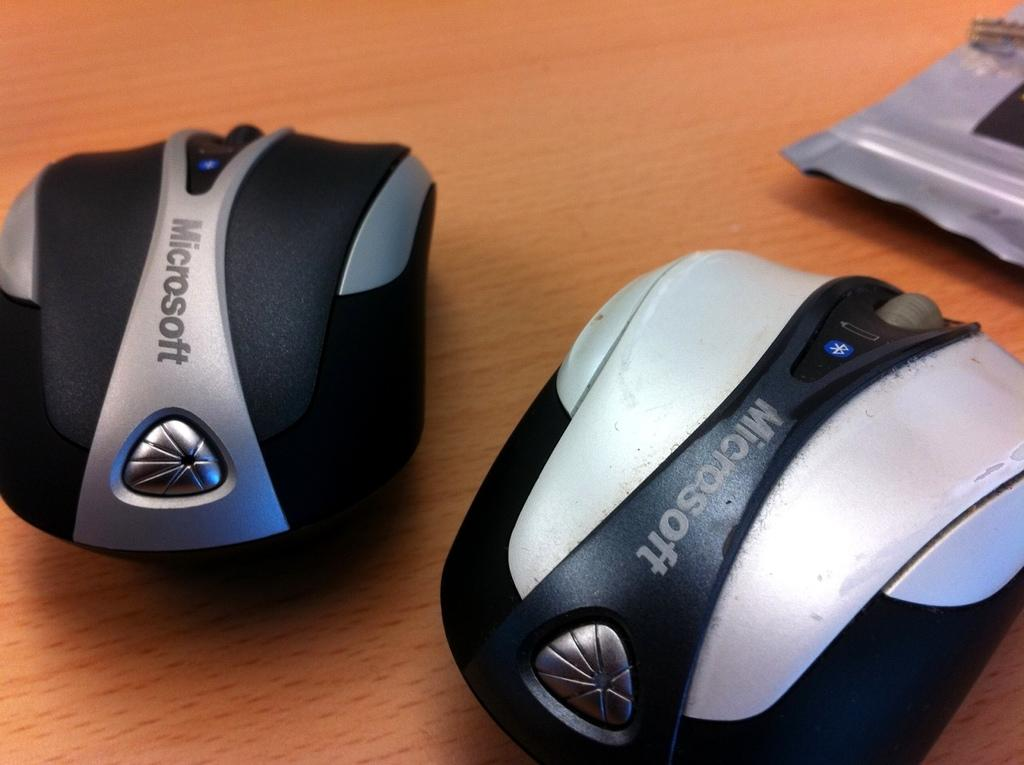What type of animals are present in the image? There are mice in the image. Can you describe the object in the image? Unfortunately, there is not enough information provided to describe the object in the image. What type of polish is being applied to the planes in the image? There are no planes present in the image, and therefore no polish is being applied to them. 